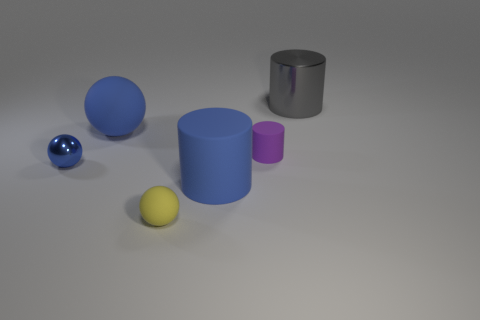There is a ball right of the blue rubber sphere; is its size the same as the tiny shiny sphere?
Give a very brief answer. Yes. There is a big cylinder to the right of the purple cylinder; what material is it?
Offer a very short reply. Metal. How many rubber things are either big gray things or big cylinders?
Offer a very short reply. 1. Is the number of small blue objects to the left of the large blue matte cylinder less than the number of small blue balls?
Offer a very short reply. No. What shape is the tiny object that is right of the large cylinder in front of the cylinder that is behind the small purple thing?
Offer a very short reply. Cylinder. Is the large ball the same color as the metal sphere?
Offer a terse response. Yes. Is the number of blue rubber spheres greater than the number of tiny brown matte cubes?
Your response must be concise. Yes. What number of other things are made of the same material as the purple cylinder?
Provide a short and direct response. 3. How many things are either gray shiny cylinders or tiny rubber things that are on the right side of the big blue matte cylinder?
Your answer should be very brief. 2. Is the number of matte cylinders less than the number of big yellow objects?
Ensure brevity in your answer.  No. 